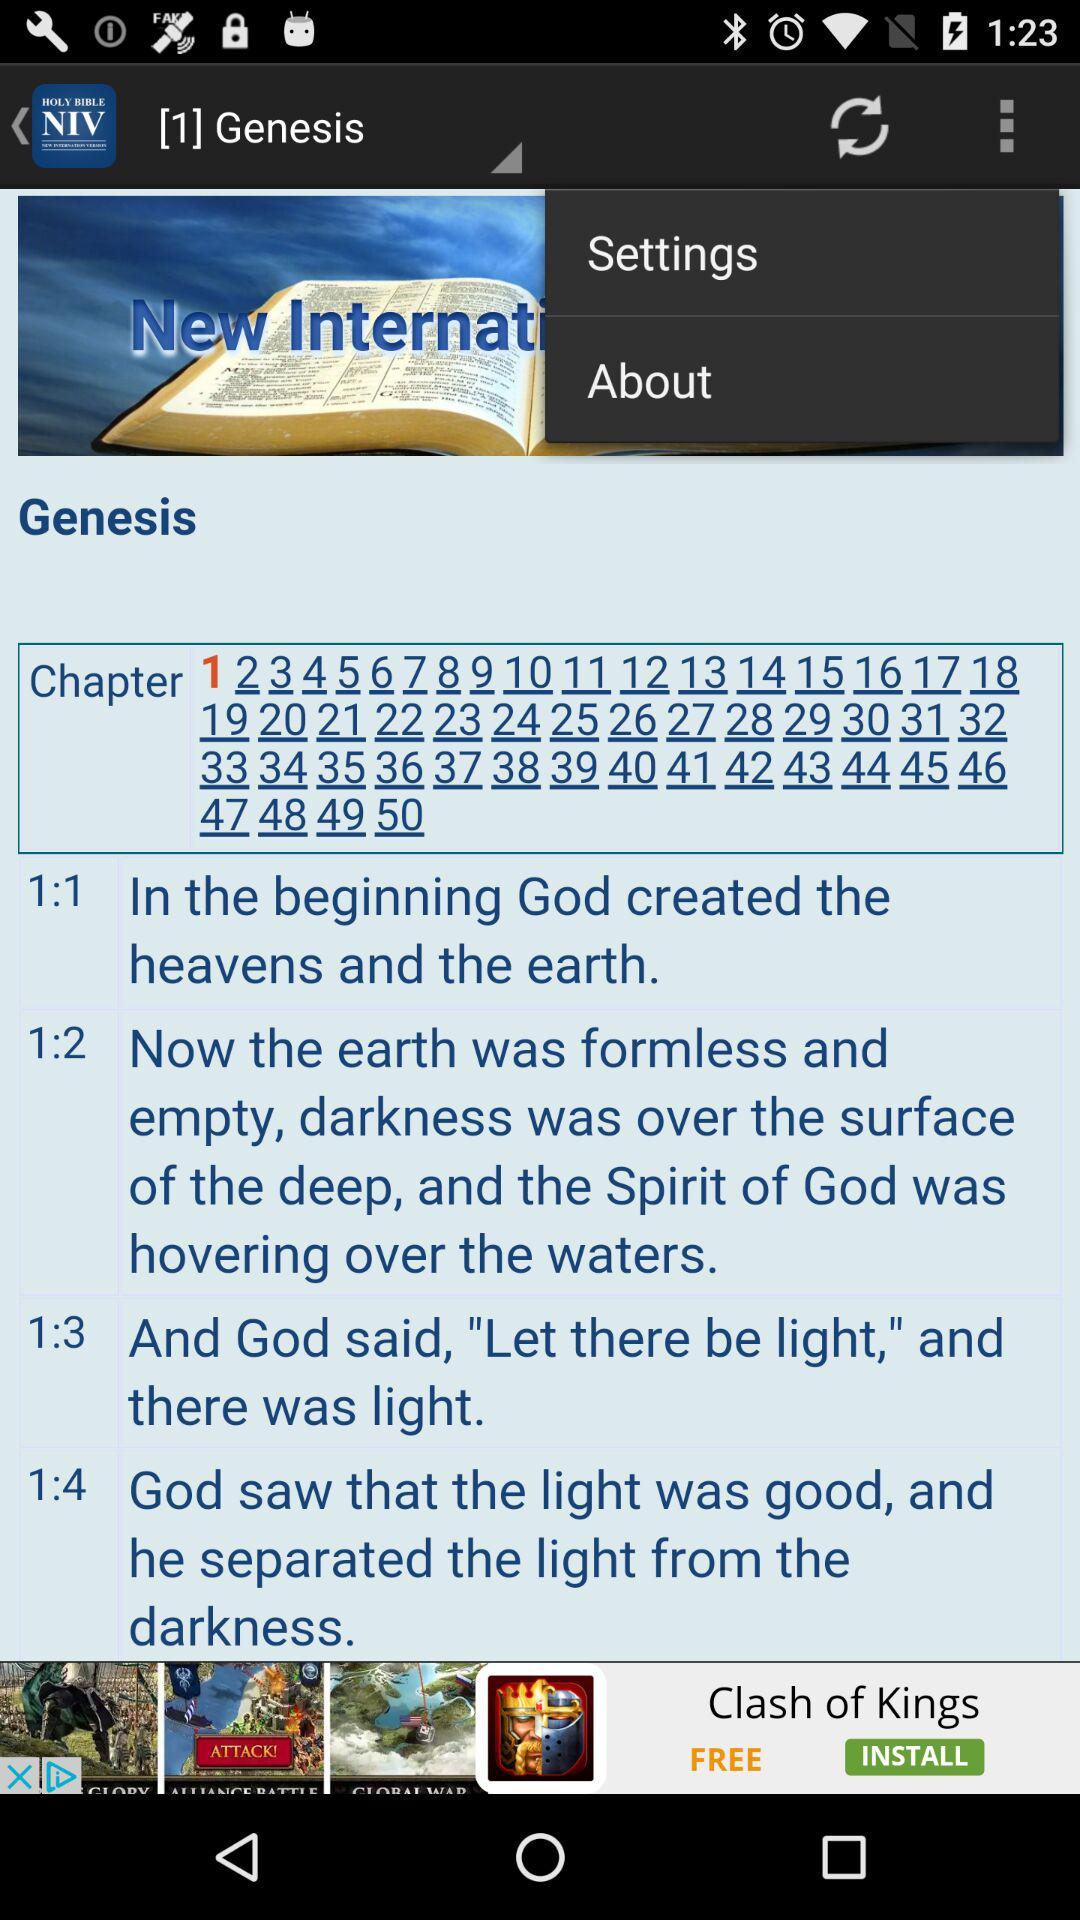How many chapters are there in Genesis?
Answer the question using a single word or phrase. 50 